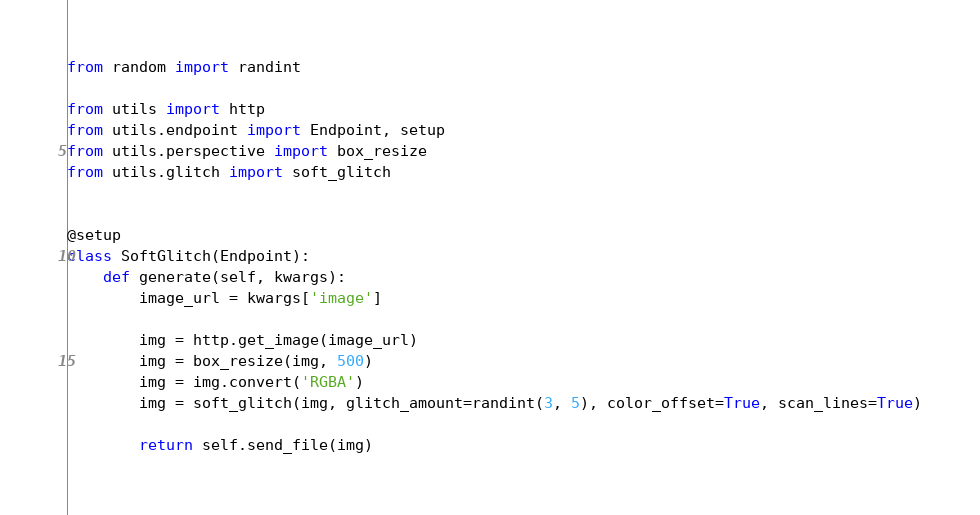<code> <loc_0><loc_0><loc_500><loc_500><_Python_>from random import randint

from utils import http
from utils.endpoint import Endpoint, setup
from utils.perspective import box_resize
from utils.glitch import soft_glitch


@setup
class SoftGlitch(Endpoint):
    def generate(self, kwargs):
        image_url = kwargs['image']

        img = http.get_image(image_url)
        img = box_resize(img, 500)
        img = img.convert('RGBA')
        img = soft_glitch(img, glitch_amount=randint(3, 5), color_offset=True, scan_lines=True)

        return self.send_file(img)</code> 